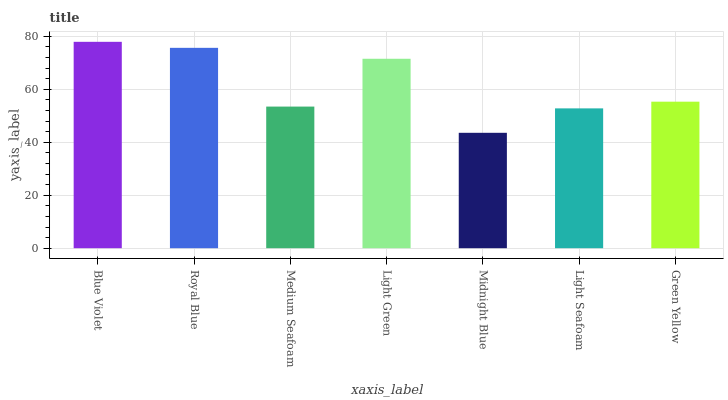Is Midnight Blue the minimum?
Answer yes or no. Yes. Is Blue Violet the maximum?
Answer yes or no. Yes. Is Royal Blue the minimum?
Answer yes or no. No. Is Royal Blue the maximum?
Answer yes or no. No. Is Blue Violet greater than Royal Blue?
Answer yes or no. Yes. Is Royal Blue less than Blue Violet?
Answer yes or no. Yes. Is Royal Blue greater than Blue Violet?
Answer yes or no. No. Is Blue Violet less than Royal Blue?
Answer yes or no. No. Is Green Yellow the high median?
Answer yes or no. Yes. Is Green Yellow the low median?
Answer yes or no. Yes. Is Medium Seafoam the high median?
Answer yes or no. No. Is Midnight Blue the low median?
Answer yes or no. No. 